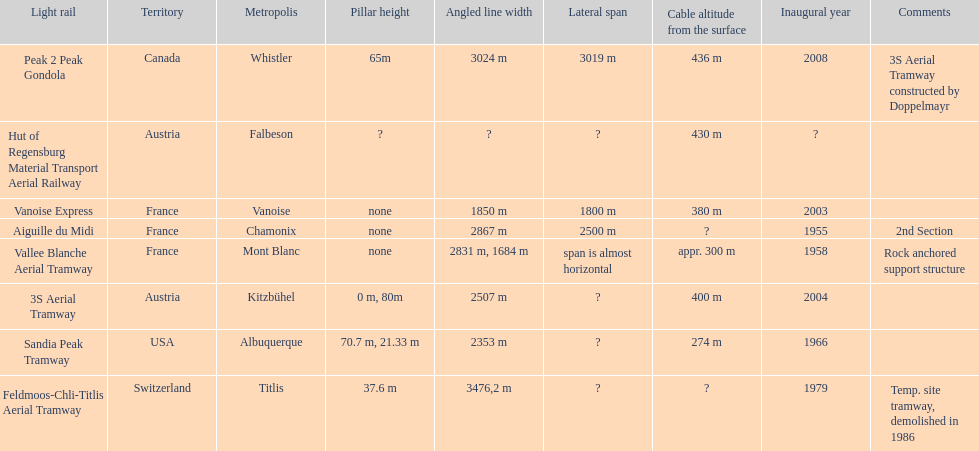Was the peak 2 peak gondola inaugurated before the vanoise express? No. 